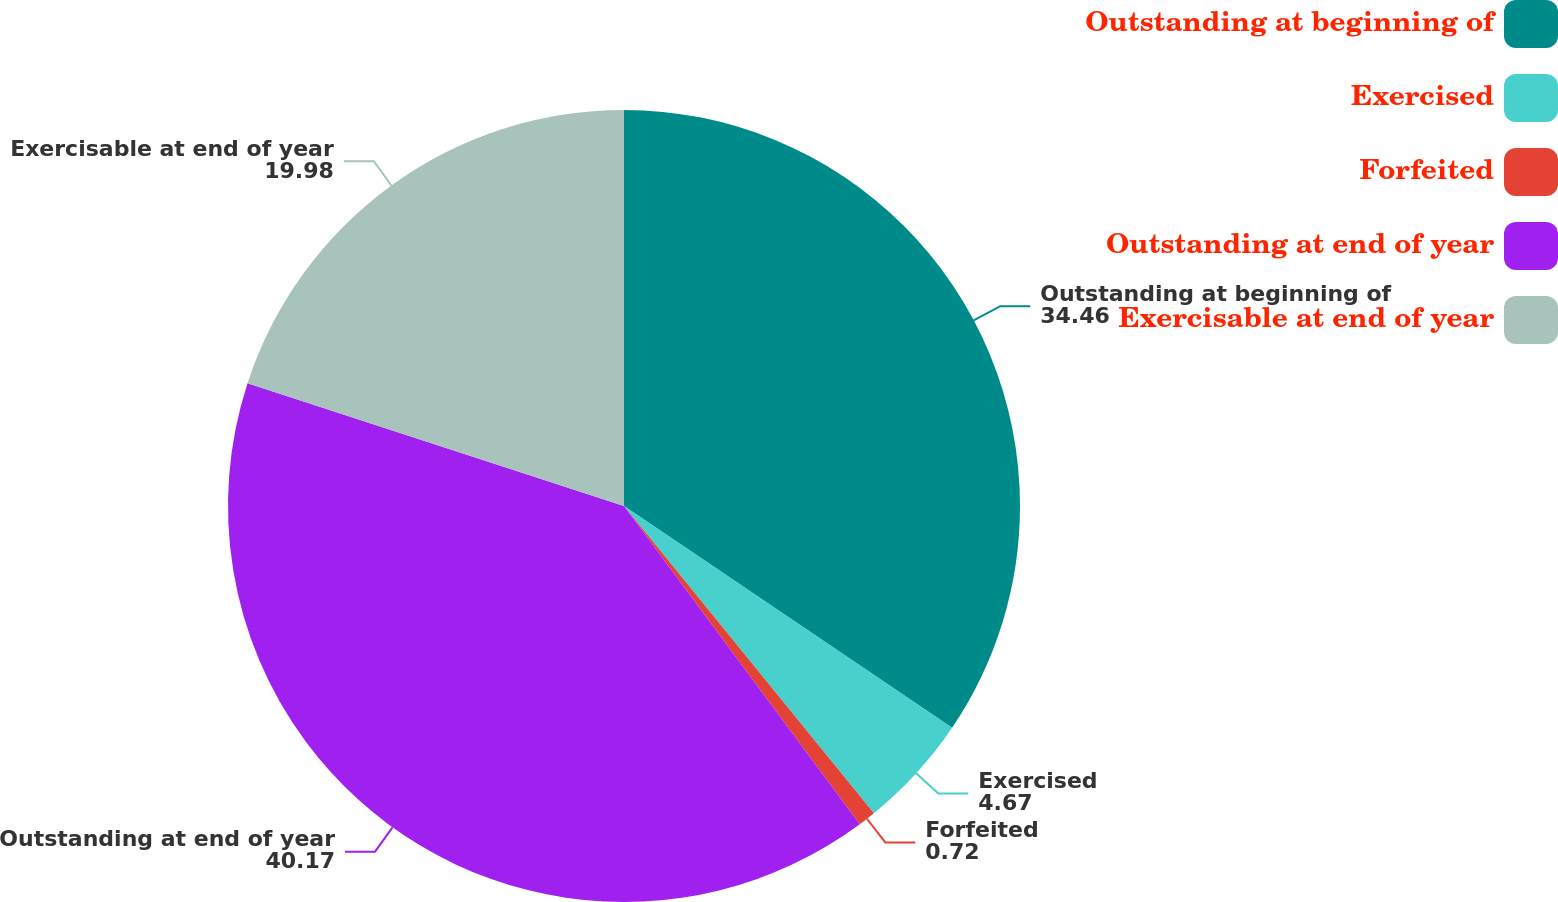Convert chart. <chart><loc_0><loc_0><loc_500><loc_500><pie_chart><fcel>Outstanding at beginning of<fcel>Exercised<fcel>Forfeited<fcel>Outstanding at end of year<fcel>Exercisable at end of year<nl><fcel>34.46%<fcel>4.67%<fcel>0.72%<fcel>40.17%<fcel>19.98%<nl></chart> 